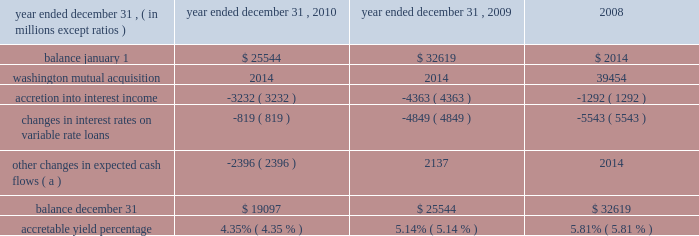Notes to consolidated financial statements 236 jpmorgan chase & co./2010 annual report the table below sets forth the accretable yield activity for the firm 2019s pci consumer loans for the years ended december 31 , 2010 , 2009 and .
( a ) other changes in expected cash flows may vary from period to period as the firm continues to refine its cash flow model and periodically updates model assumptions .
For the years ended december 31 , 2010 and 2009 , other changes in expected cash flows were principally driven by changes in prepayment assumptions , as well as reclassification to the nonaccretable difference .
Such changes are expected to have an insignificant impact on the accretable yield percentage .
The factors that most significantly affect estimates of gross cash flows expected to be collected , and accordingly the accretable yield balance , include : ( i ) changes in the benchmark interest rate indices for variable rate products such as option arm and home equity loans ; and ( ii ) changes in prepayment assump- tions .
To date , the decrease in the accretable yield percentage has been primarily related to a decrease in interest rates on vari- able-rate loans and , to a lesser extent , extended loan liquida- tion periods .
Certain events , such as extended loan liquidation periods , affect the timing of expected cash flows but not the amount of cash expected to be received ( i.e. , the accretable yield balance ) .
Extended loan liquidation periods reduce the accretable yield percentage because the same accretable yield balance is recognized against a higher-than-expected loan balance over a longer-than-expected period of time. .
What was the highest three year accretable yield percentage? 
Computations: table_max(accretable yield percentage, none)
Answer: 0.0581. 